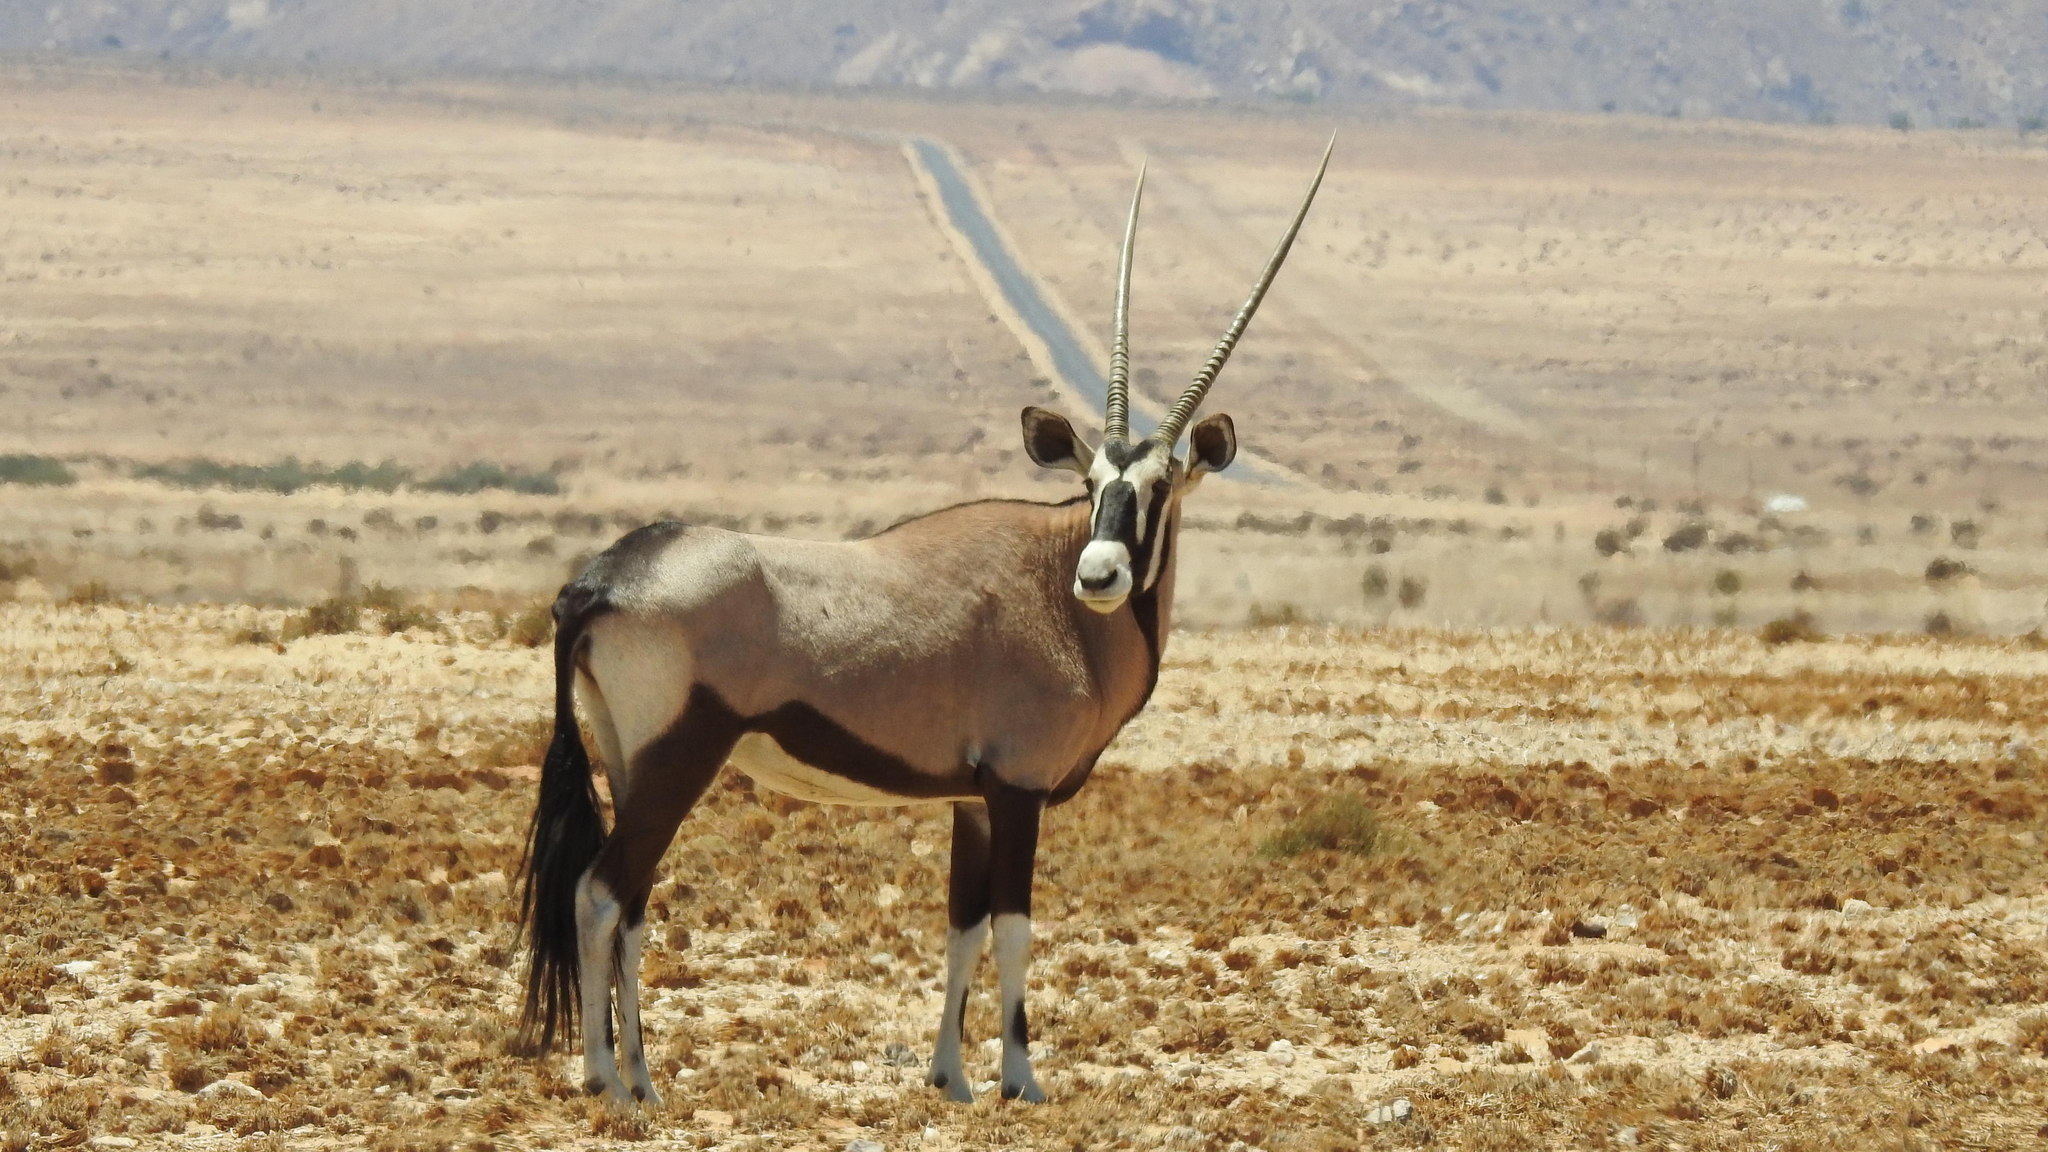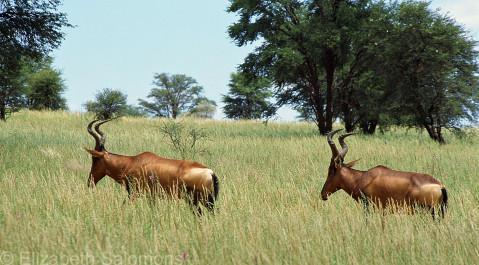The first image is the image on the left, the second image is the image on the right. Examine the images to the left and right. Is the description "There are at least four animals in the image on the right." accurate? Answer yes or no. No. 